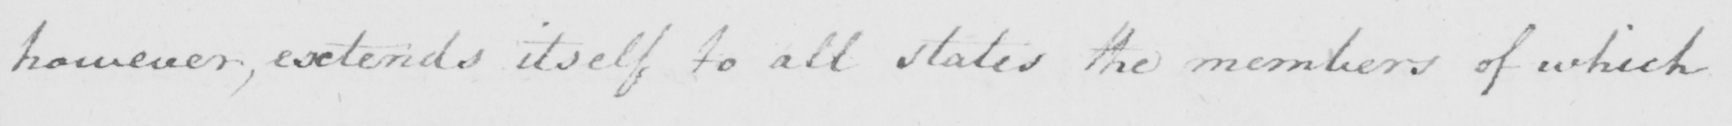Transcribe the text shown in this historical manuscript line. however, extends itself to all states the members of which 